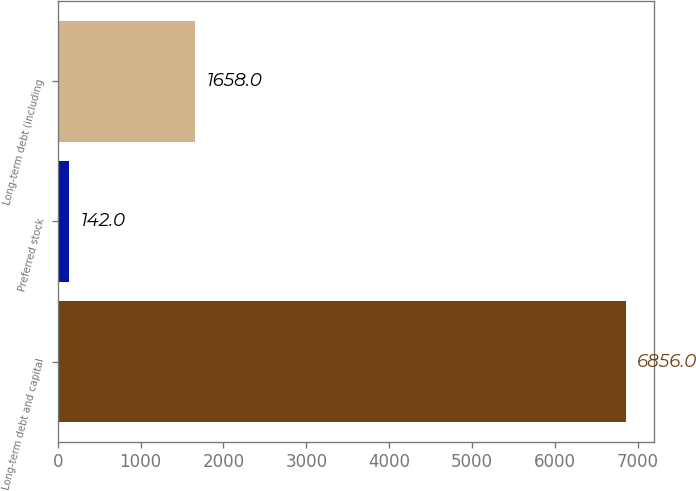<chart> <loc_0><loc_0><loc_500><loc_500><bar_chart><fcel>Long-term debt and capital<fcel>Preferred stock<fcel>Long-term debt (including<nl><fcel>6856<fcel>142<fcel>1658<nl></chart> 